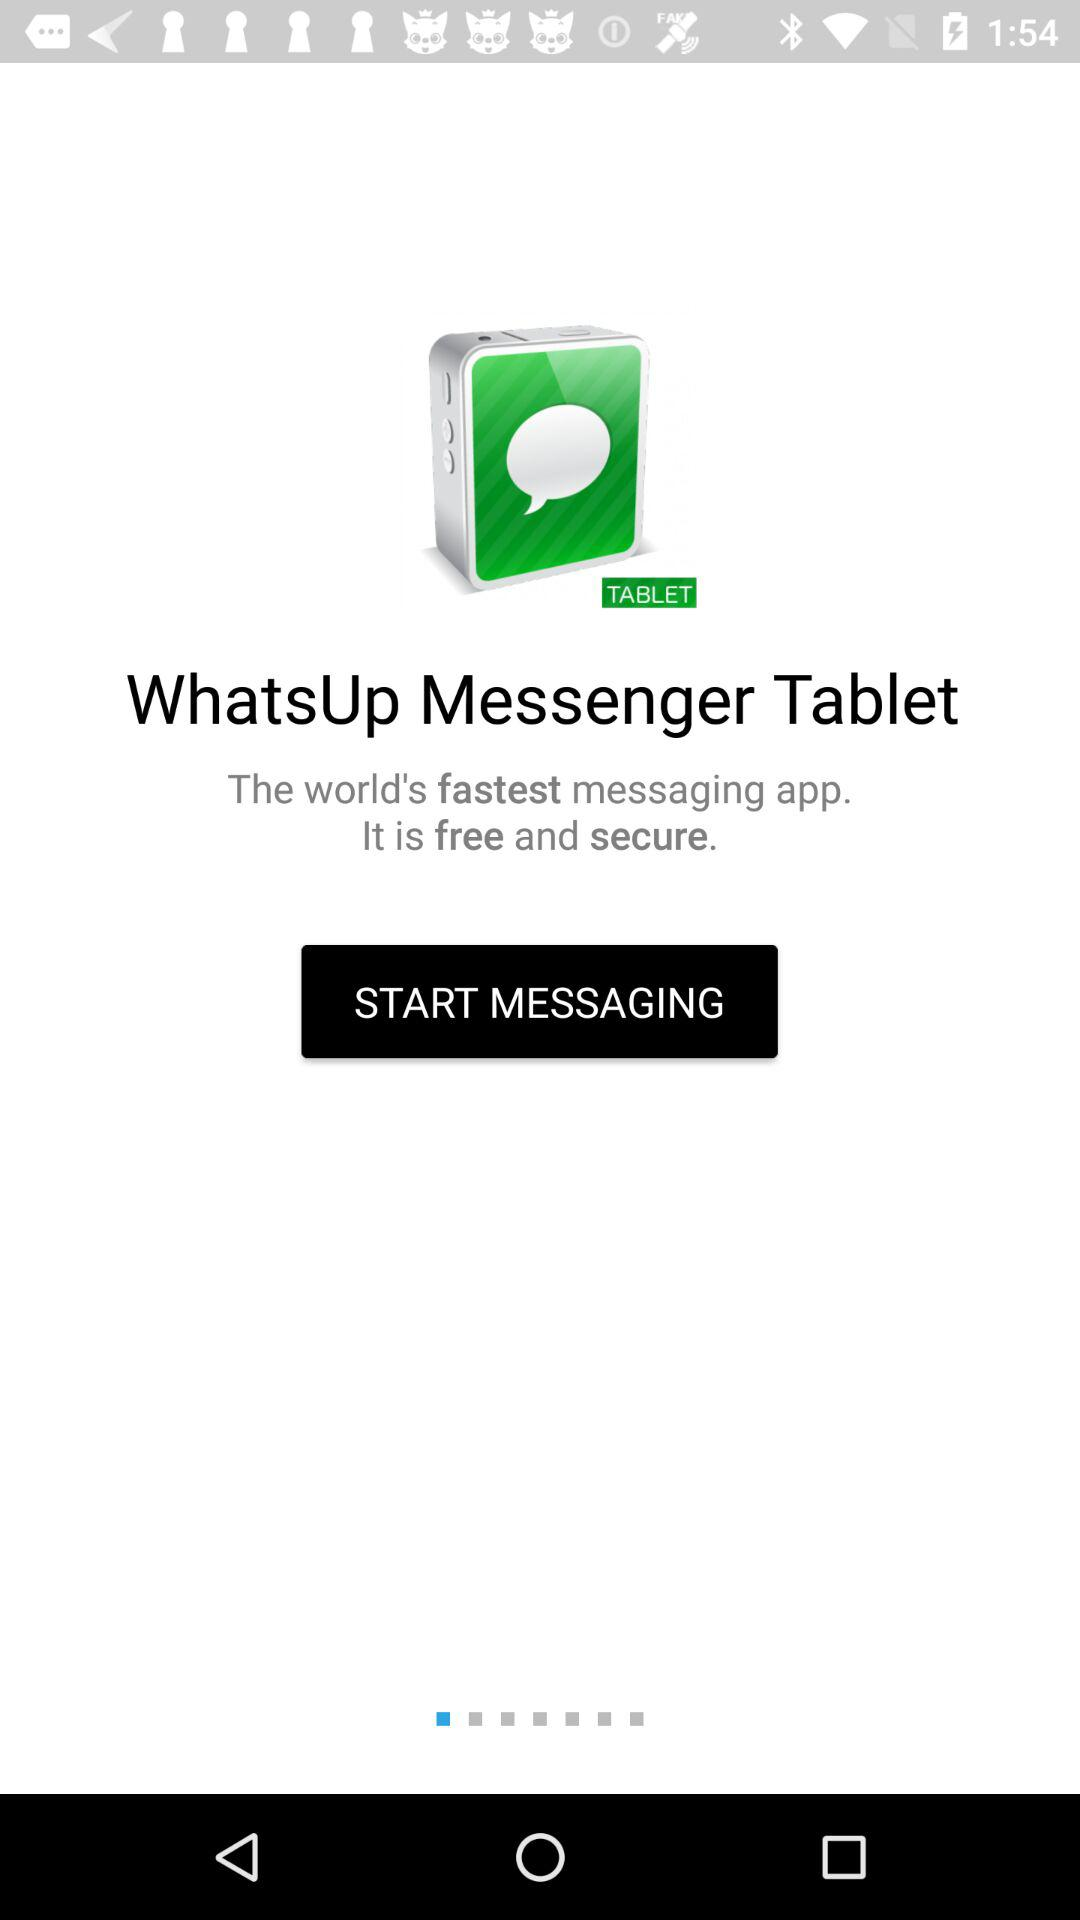What is the name of the application? The name of the application is "WhatsUp Messenger Tablet". 